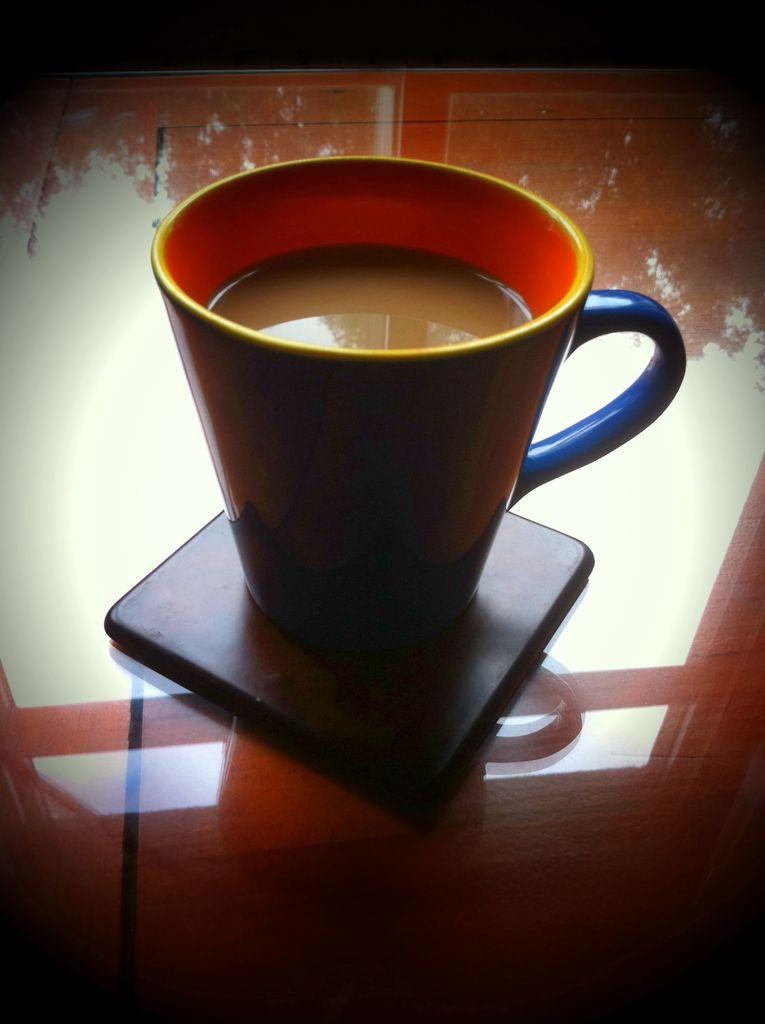What is on the stand in the image? There is a cup on the stand in the image. What is inside the cup? The cup contains tea. Where are the cup and stand located? Both the cup and stand are on a table. How many mice are crawling on the table in the image? There are no mice present in the image. What type of earth is visible in the image? There is no earth visible in the image; it is a close-up of a cup and stand on a table. 